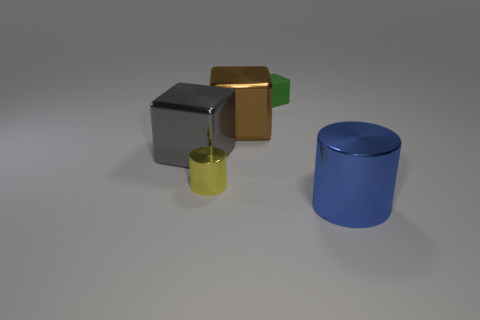Can you describe the objects' colors and shapes? Certainly! The scene showcases a collection of geometric shapes. From left to right, there's a grey cube, a smaller golden cube, a tiny green cube, a miniature yellow cylinder, and a larger blue cylinder. 